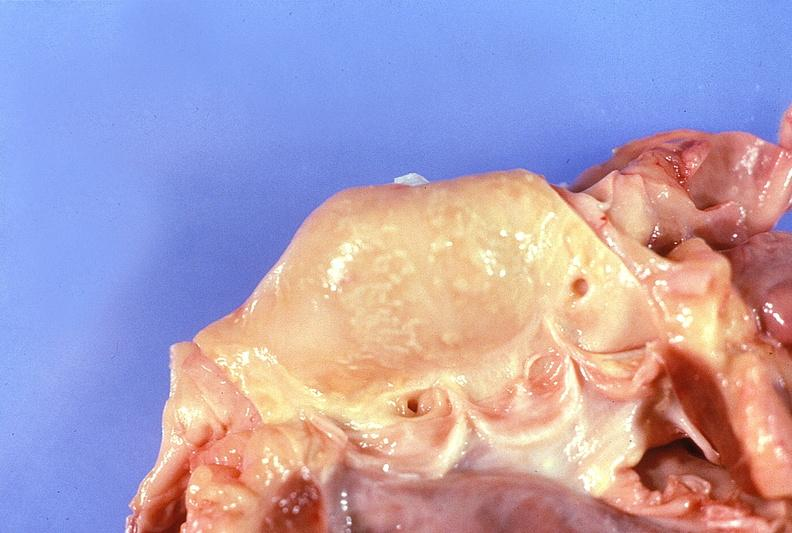what is present?
Answer the question using a single word or phrase. Cardiovascular 